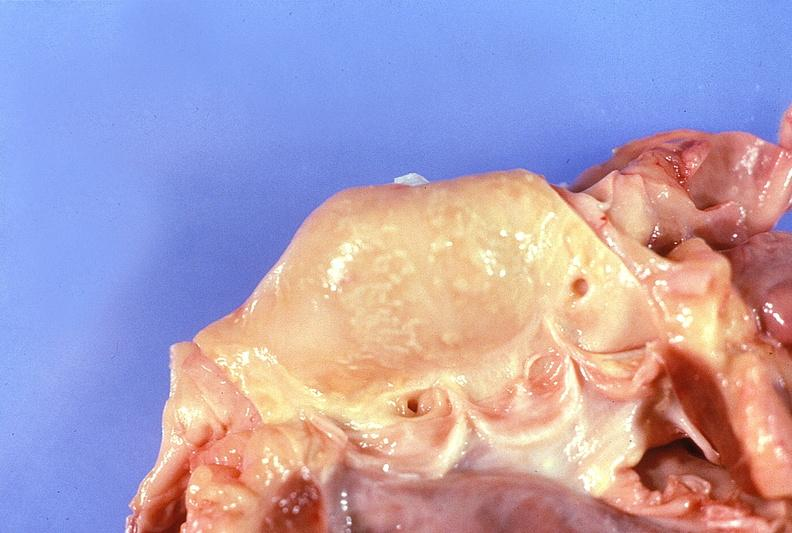what is present?
Answer the question using a single word or phrase. Cardiovascular 